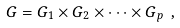Convert formula to latex. <formula><loc_0><loc_0><loc_500><loc_500>G = G _ { 1 } \times G _ { 2 } \times \dots \times G _ { p } \ ,</formula> 